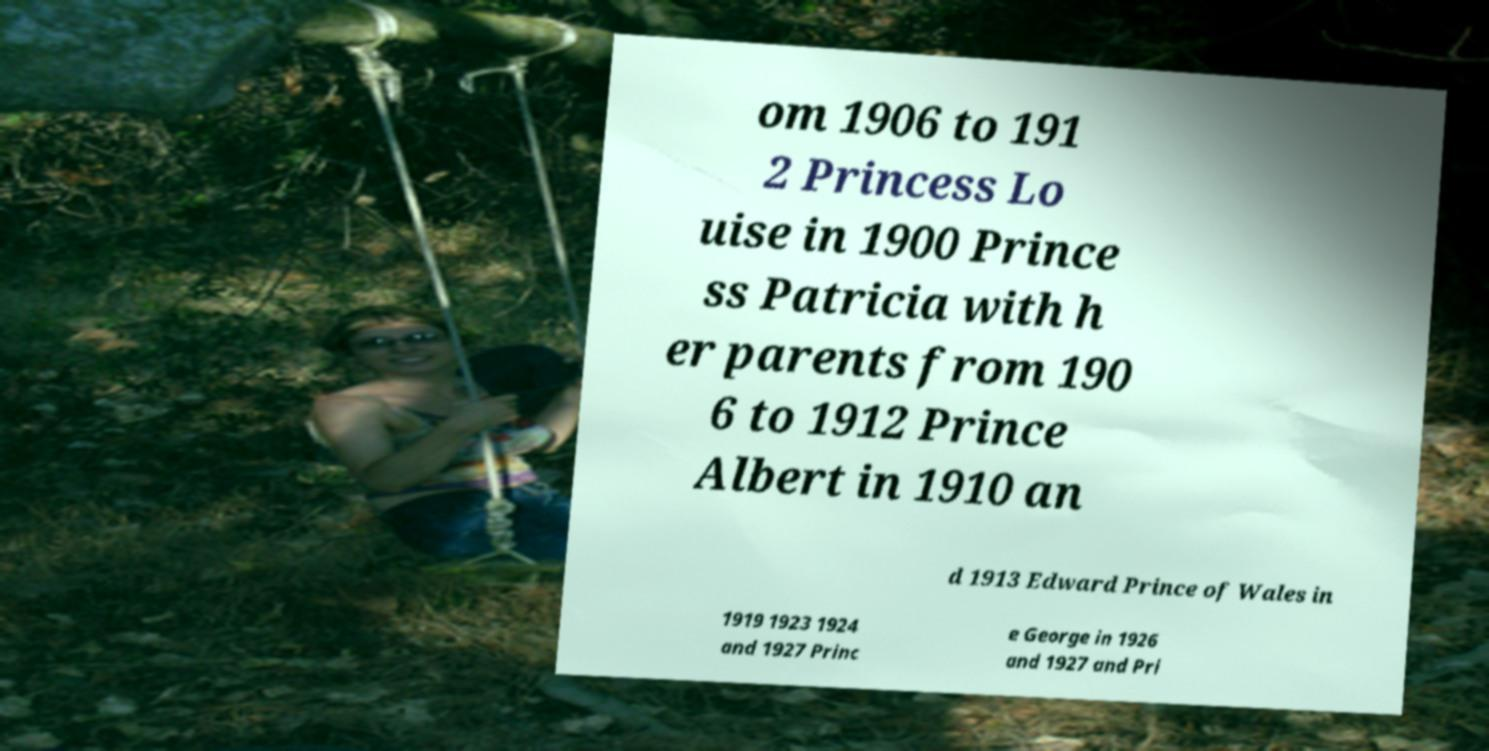Could you assist in decoding the text presented in this image and type it out clearly? om 1906 to 191 2 Princess Lo uise in 1900 Prince ss Patricia with h er parents from 190 6 to 1912 Prince Albert in 1910 an d 1913 Edward Prince of Wales in 1919 1923 1924 and 1927 Princ e George in 1926 and 1927 and Pri 